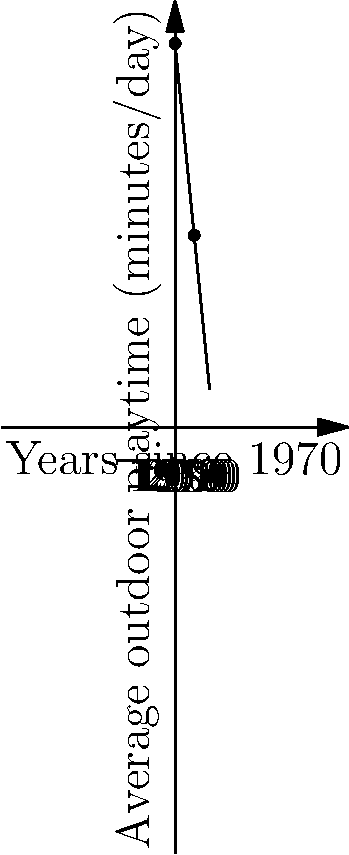The graph shows the average daily outdoor playtime for children from 1970 to 2020. What was the rate of change in children's outdoor playtime per decade during this period? To find the rate of change per decade, we need to:

1. Identify two points on the line:
   - In 1970 (0 decades since 1970): 100 minutes
   - In 2020 (5 decades since 1970): 50 minutes

2. Calculate the total change in playtime:
   $\text{Change in playtime} = 50 - 100 = -50$ minutes

3. Calculate the time span:
   $\text{Time span} = 5$ decades

4. Use the formula for rate of change:
   $\text{Rate of change} = \frac{\text{Change in y}}{\text{Change in x}} = \frac{\text{Change in playtime}}{\text{Time span}}$

5. Plug in the values:
   $\text{Rate of change} = \frac{-50 \text{ minutes}}{5 \text{ decades}} = -10 \text{ minutes per decade}$

The negative sign indicates a decrease in playtime over the decades.
Answer: $-10$ minutes per decade 